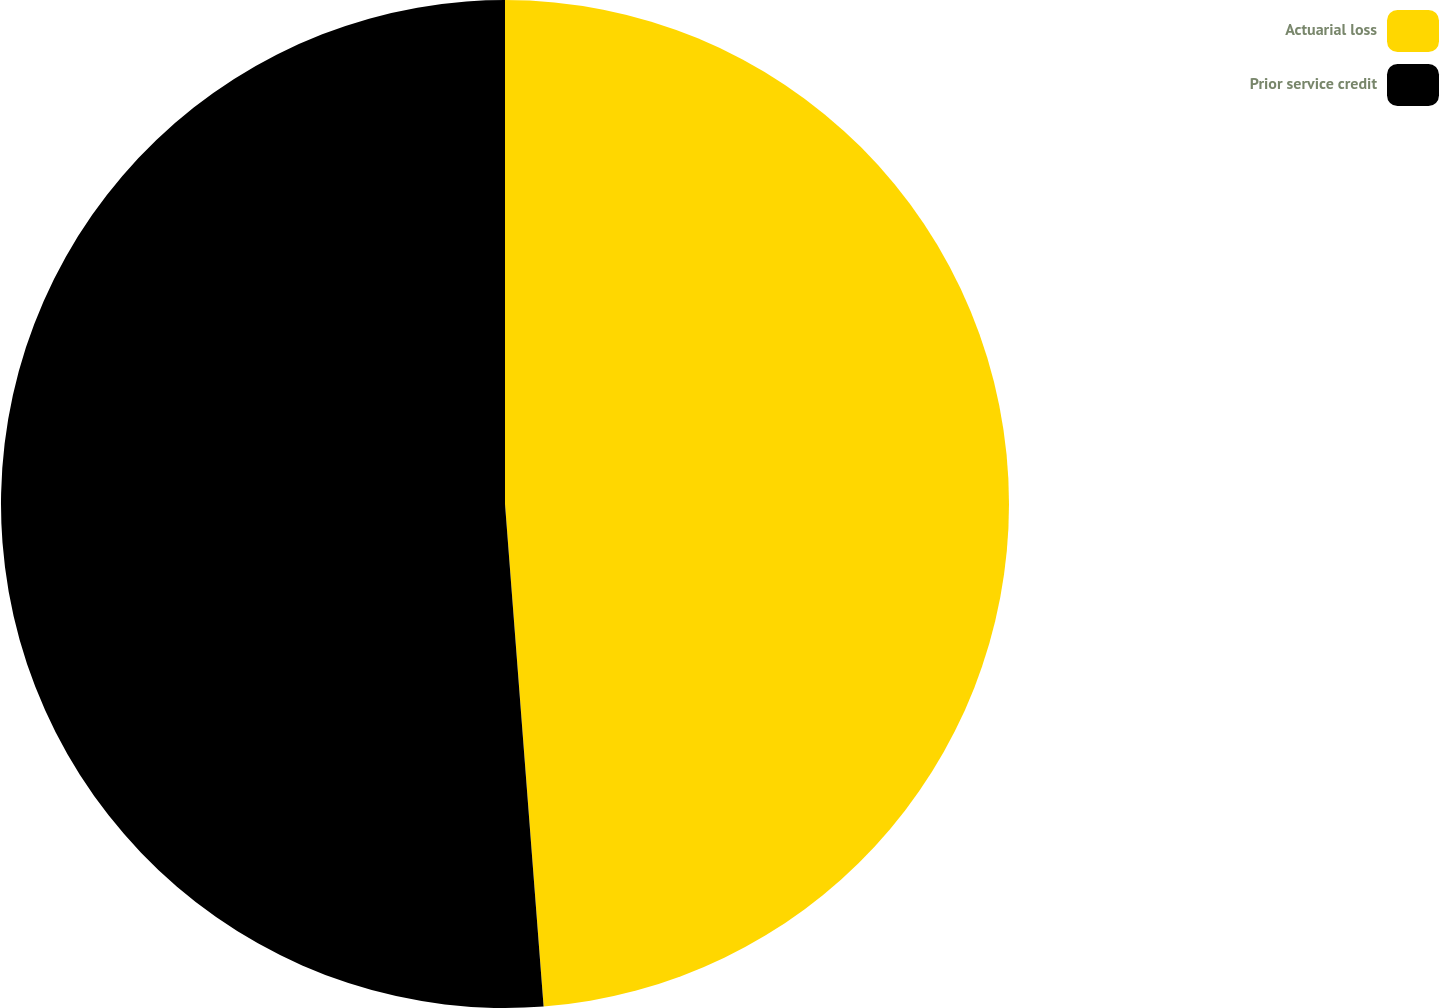Convert chart. <chart><loc_0><loc_0><loc_500><loc_500><pie_chart><fcel>Actuarial loss<fcel>Prior service credit<nl><fcel>48.78%<fcel>51.22%<nl></chart> 